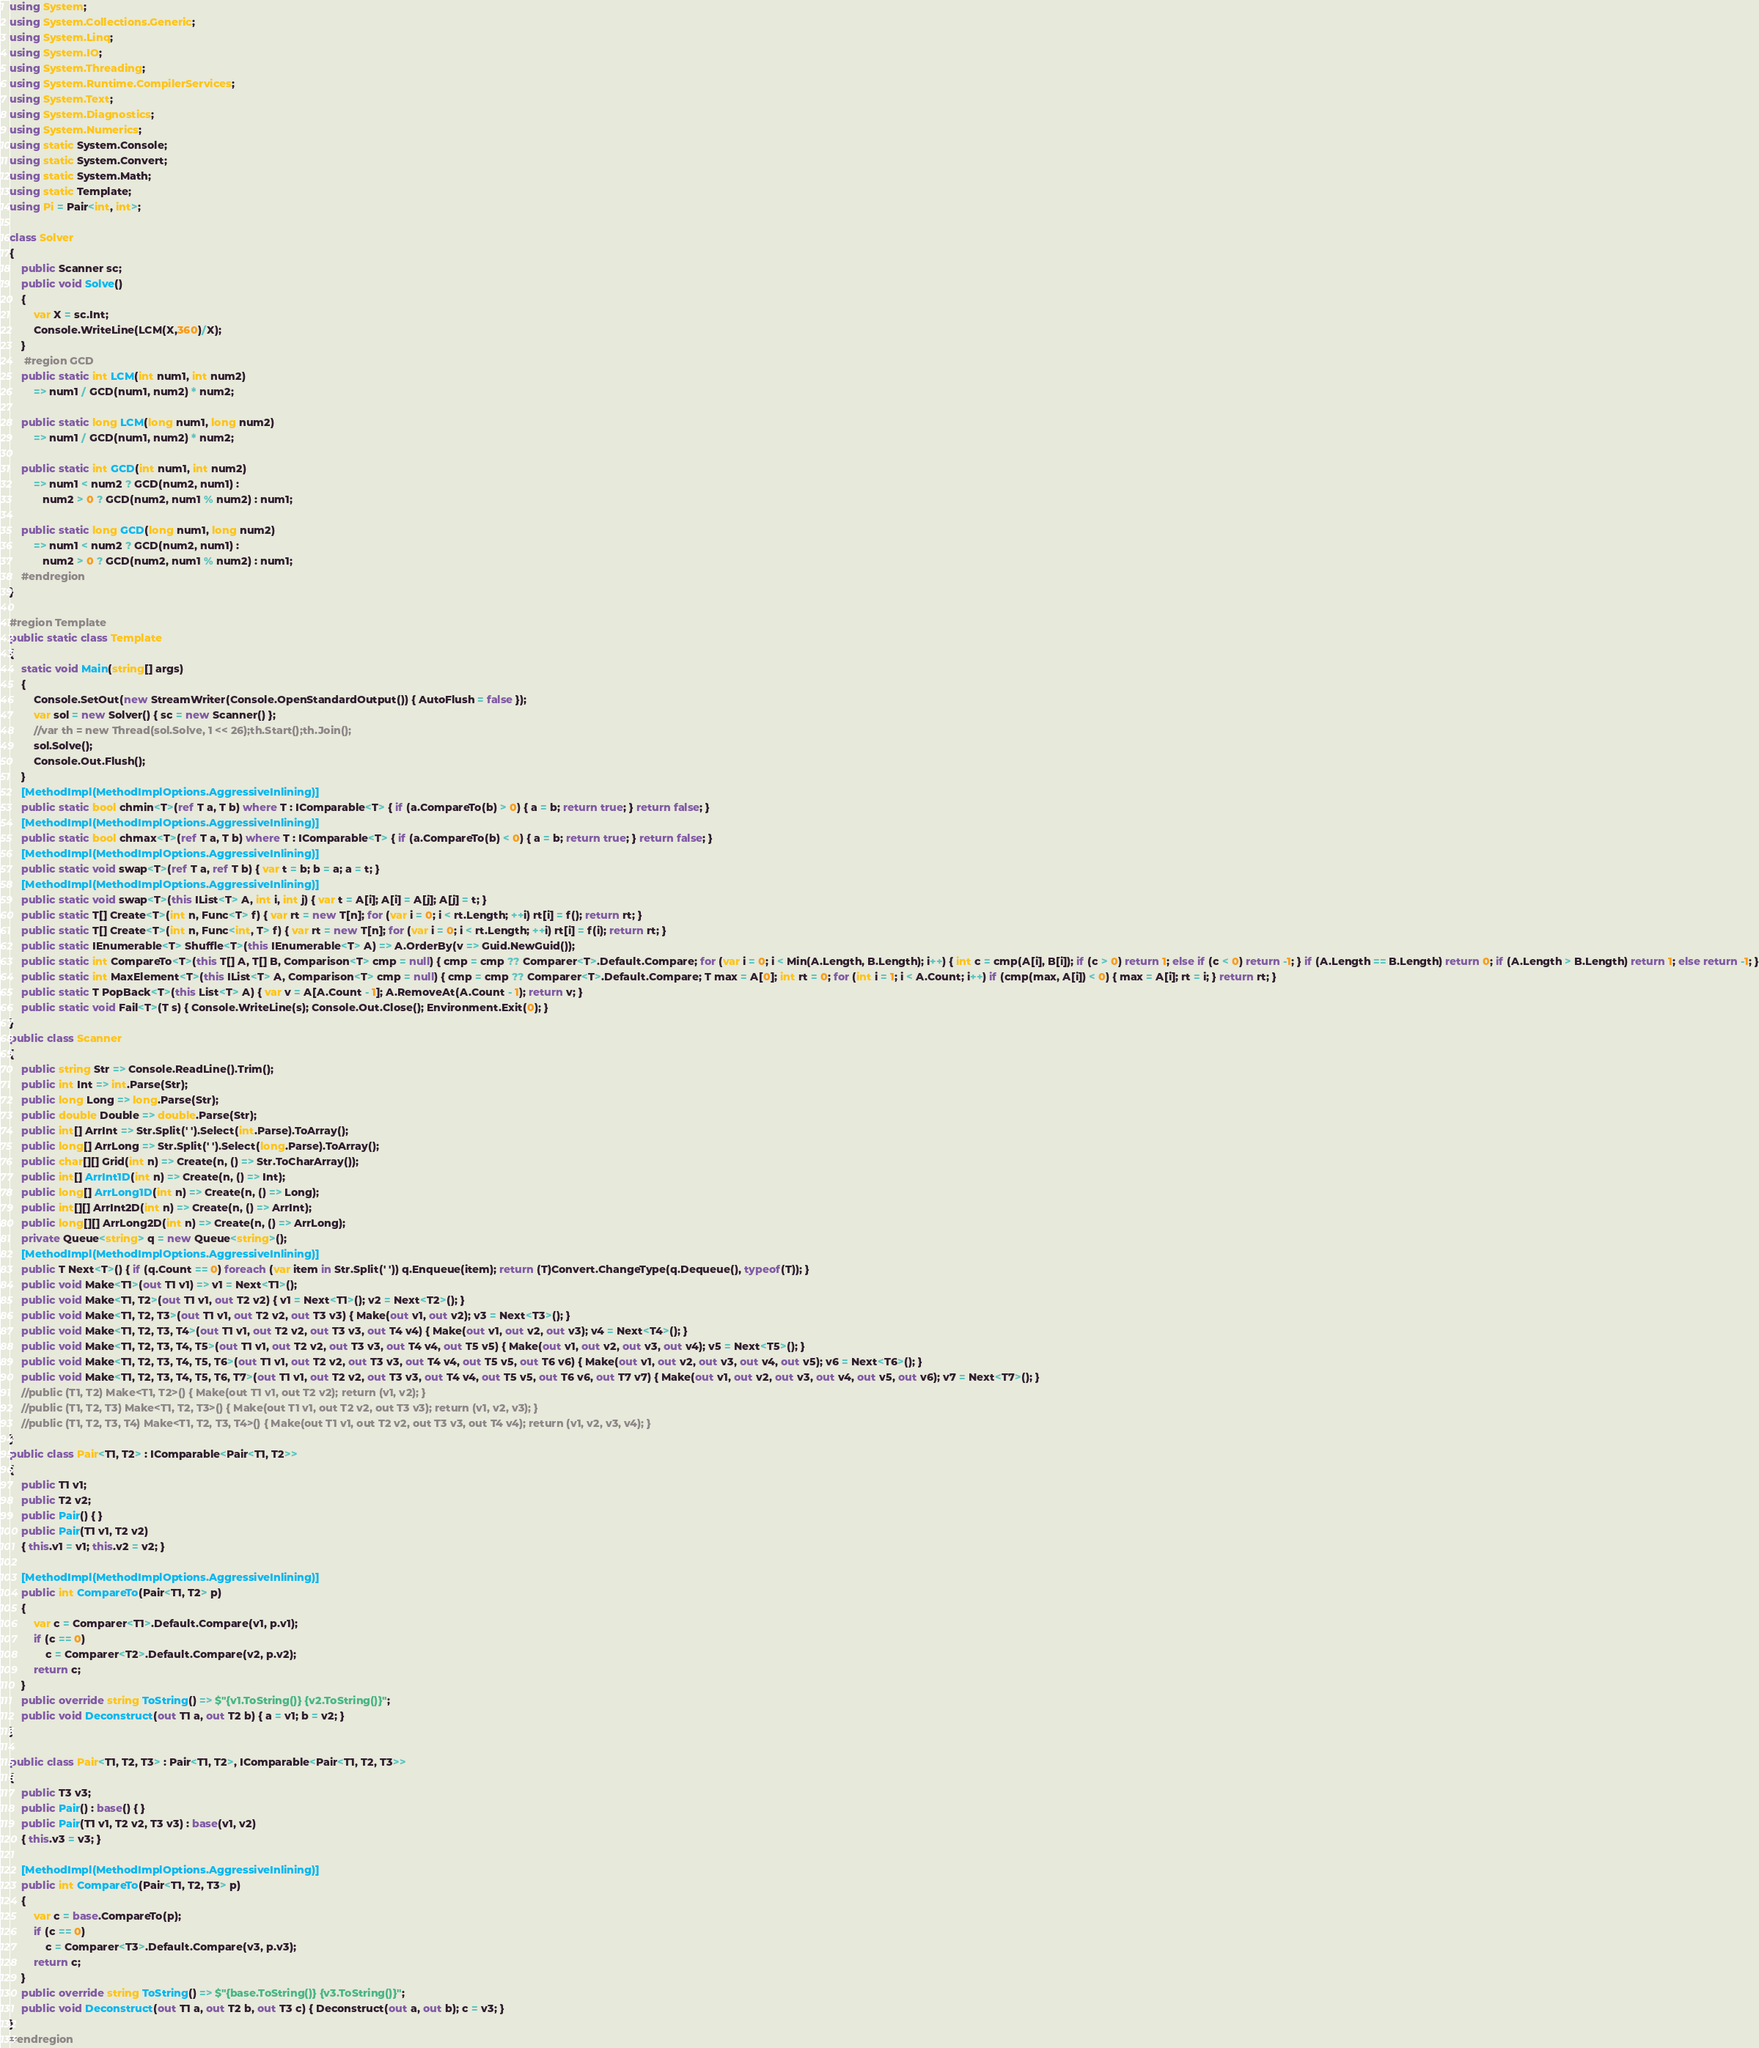Convert code to text. <code><loc_0><loc_0><loc_500><loc_500><_C#_>using System;
using System.Collections.Generic;
using System.Linq;
using System.IO;
using System.Threading;
using System.Runtime.CompilerServices;
using System.Text;
using System.Diagnostics;
using System.Numerics;
using static System.Console;
using static System.Convert;
using static System.Math;
using static Template;
using Pi = Pair<int, int>;

class Solver
{
    public Scanner sc;
    public void Solve()
    {
        var X = sc.Int;
        Console.WriteLine(LCM(X,360)/X);
    }
     #region GCD
    public static int LCM(int num1, int num2)
        => num1 / GCD(num1, num2) * num2;

    public static long LCM(long num1, long num2)
        => num1 / GCD(num1, num2) * num2;

    public static int GCD(int num1, int num2)
        => num1 < num2 ? GCD(num2, num1) :
           num2 > 0 ? GCD(num2, num1 % num2) : num1;

    public static long GCD(long num1, long num2)
        => num1 < num2 ? GCD(num2, num1) :
           num2 > 0 ? GCD(num2, num1 % num2) : num1;
    #endregion
}

#region Template
public static class Template
{
    static void Main(string[] args)
    {
        Console.SetOut(new StreamWriter(Console.OpenStandardOutput()) { AutoFlush = false });
        var sol = new Solver() { sc = new Scanner() };
        //var th = new Thread(sol.Solve, 1 << 26);th.Start();th.Join();
        sol.Solve();
        Console.Out.Flush();
    }
    [MethodImpl(MethodImplOptions.AggressiveInlining)]
    public static bool chmin<T>(ref T a, T b) where T : IComparable<T> { if (a.CompareTo(b) > 0) { a = b; return true; } return false; }
    [MethodImpl(MethodImplOptions.AggressiveInlining)]
    public static bool chmax<T>(ref T a, T b) where T : IComparable<T> { if (a.CompareTo(b) < 0) { a = b; return true; } return false; }
    [MethodImpl(MethodImplOptions.AggressiveInlining)]
    public static void swap<T>(ref T a, ref T b) { var t = b; b = a; a = t; }
    [MethodImpl(MethodImplOptions.AggressiveInlining)]
    public static void swap<T>(this IList<T> A, int i, int j) { var t = A[i]; A[i] = A[j]; A[j] = t; }
    public static T[] Create<T>(int n, Func<T> f) { var rt = new T[n]; for (var i = 0; i < rt.Length; ++i) rt[i] = f(); return rt; }
    public static T[] Create<T>(int n, Func<int, T> f) { var rt = new T[n]; for (var i = 0; i < rt.Length; ++i) rt[i] = f(i); return rt; }
    public static IEnumerable<T> Shuffle<T>(this IEnumerable<T> A) => A.OrderBy(v => Guid.NewGuid());
    public static int CompareTo<T>(this T[] A, T[] B, Comparison<T> cmp = null) { cmp = cmp ?? Comparer<T>.Default.Compare; for (var i = 0; i < Min(A.Length, B.Length); i++) { int c = cmp(A[i], B[i]); if (c > 0) return 1; else if (c < 0) return -1; } if (A.Length == B.Length) return 0; if (A.Length > B.Length) return 1; else return -1; }
    public static int MaxElement<T>(this IList<T> A, Comparison<T> cmp = null) { cmp = cmp ?? Comparer<T>.Default.Compare; T max = A[0]; int rt = 0; for (int i = 1; i < A.Count; i++) if (cmp(max, A[i]) < 0) { max = A[i]; rt = i; } return rt; }
    public static T PopBack<T>(this List<T> A) { var v = A[A.Count - 1]; A.RemoveAt(A.Count - 1); return v; }
    public static void Fail<T>(T s) { Console.WriteLine(s); Console.Out.Close(); Environment.Exit(0); }
}
public class Scanner
{
    public string Str => Console.ReadLine().Trim();
    public int Int => int.Parse(Str);
    public long Long => long.Parse(Str);
    public double Double => double.Parse(Str);
    public int[] ArrInt => Str.Split(' ').Select(int.Parse).ToArray();
    public long[] ArrLong => Str.Split(' ').Select(long.Parse).ToArray();
    public char[][] Grid(int n) => Create(n, () => Str.ToCharArray());
    public int[] ArrInt1D(int n) => Create(n, () => Int);
    public long[] ArrLong1D(int n) => Create(n, () => Long);
    public int[][] ArrInt2D(int n) => Create(n, () => ArrInt);
    public long[][] ArrLong2D(int n) => Create(n, () => ArrLong);
    private Queue<string> q = new Queue<string>();
    [MethodImpl(MethodImplOptions.AggressiveInlining)]
    public T Next<T>() { if (q.Count == 0) foreach (var item in Str.Split(' ')) q.Enqueue(item); return (T)Convert.ChangeType(q.Dequeue(), typeof(T)); }
    public void Make<T1>(out T1 v1) => v1 = Next<T1>();
    public void Make<T1, T2>(out T1 v1, out T2 v2) { v1 = Next<T1>(); v2 = Next<T2>(); }
    public void Make<T1, T2, T3>(out T1 v1, out T2 v2, out T3 v3) { Make(out v1, out v2); v3 = Next<T3>(); }
    public void Make<T1, T2, T3, T4>(out T1 v1, out T2 v2, out T3 v3, out T4 v4) { Make(out v1, out v2, out v3); v4 = Next<T4>(); }
    public void Make<T1, T2, T3, T4, T5>(out T1 v1, out T2 v2, out T3 v3, out T4 v4, out T5 v5) { Make(out v1, out v2, out v3, out v4); v5 = Next<T5>(); }
    public void Make<T1, T2, T3, T4, T5, T6>(out T1 v1, out T2 v2, out T3 v3, out T4 v4, out T5 v5, out T6 v6) { Make(out v1, out v2, out v3, out v4, out v5); v6 = Next<T6>(); }
    public void Make<T1, T2, T3, T4, T5, T6, T7>(out T1 v1, out T2 v2, out T3 v3, out T4 v4, out T5 v5, out T6 v6, out T7 v7) { Make(out v1, out v2, out v3, out v4, out v5, out v6); v7 = Next<T7>(); }
    //public (T1, T2) Make<T1, T2>() { Make(out T1 v1, out T2 v2); return (v1, v2); }
    //public (T1, T2, T3) Make<T1, T2, T3>() { Make(out T1 v1, out T2 v2, out T3 v3); return (v1, v2, v3); }
    //public (T1, T2, T3, T4) Make<T1, T2, T3, T4>() { Make(out T1 v1, out T2 v2, out T3 v3, out T4 v4); return (v1, v2, v3, v4); }
}
public class Pair<T1, T2> : IComparable<Pair<T1, T2>>
{
    public T1 v1;
    public T2 v2;
    public Pair() { }
    public Pair(T1 v1, T2 v2)
    { this.v1 = v1; this.v2 = v2; }

    [MethodImpl(MethodImplOptions.AggressiveInlining)]
    public int CompareTo(Pair<T1, T2> p)
    {
        var c = Comparer<T1>.Default.Compare(v1, p.v1);
        if (c == 0)
            c = Comparer<T2>.Default.Compare(v2, p.v2);
        return c;
    }
    public override string ToString() => $"{v1.ToString()} {v2.ToString()}";
    public void Deconstruct(out T1 a, out T2 b) { a = v1; b = v2; }
}

public class Pair<T1, T2, T3> : Pair<T1, T2>, IComparable<Pair<T1, T2, T3>>
{
    public T3 v3;
    public Pair() : base() { }
    public Pair(T1 v1, T2 v2, T3 v3) : base(v1, v2)
    { this.v3 = v3; }

    [MethodImpl(MethodImplOptions.AggressiveInlining)]
    public int CompareTo(Pair<T1, T2, T3> p)
    {
        var c = base.CompareTo(p);
        if (c == 0)
            c = Comparer<T3>.Default.Compare(v3, p.v3);
        return c;
    }
    public override string ToString() => $"{base.ToString()} {v3.ToString()}";
    public void Deconstruct(out T1 a, out T2 b, out T3 c) { Deconstruct(out a, out b); c = v3; }
}
#endregion

</code> 